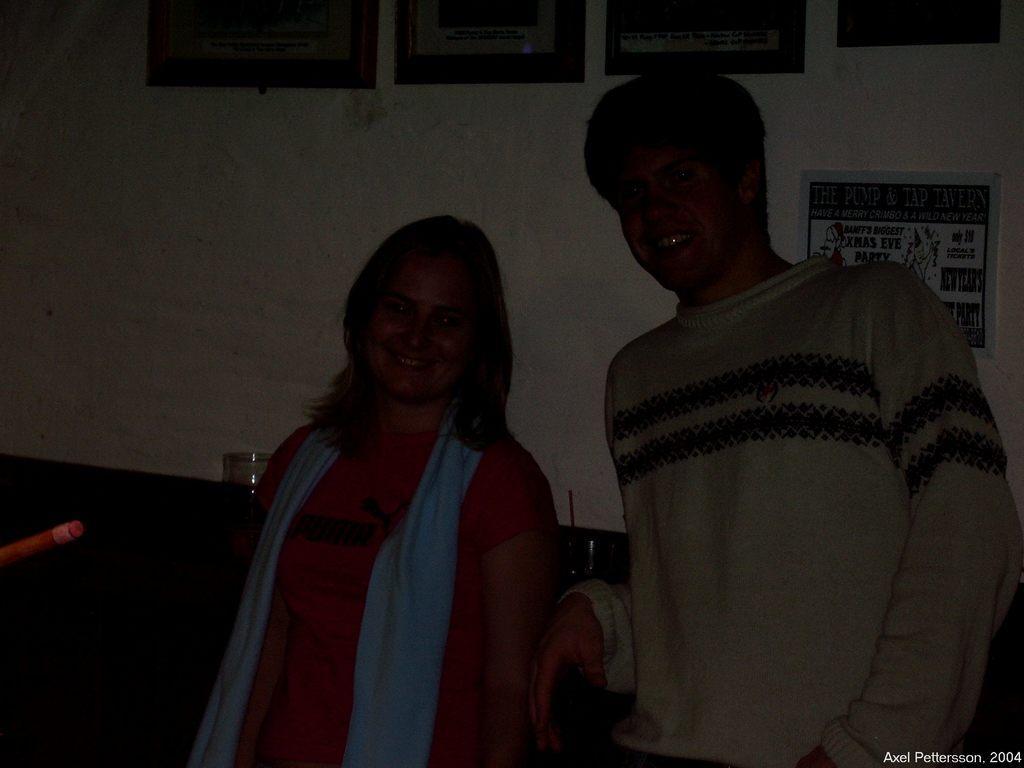How would you summarize this image in a sentence or two? In this image we can see male person wearing grey color T-shirt, female wearing pink color T-shirt standing and in the background of the image there is a wall to which there are some paintings attached. 